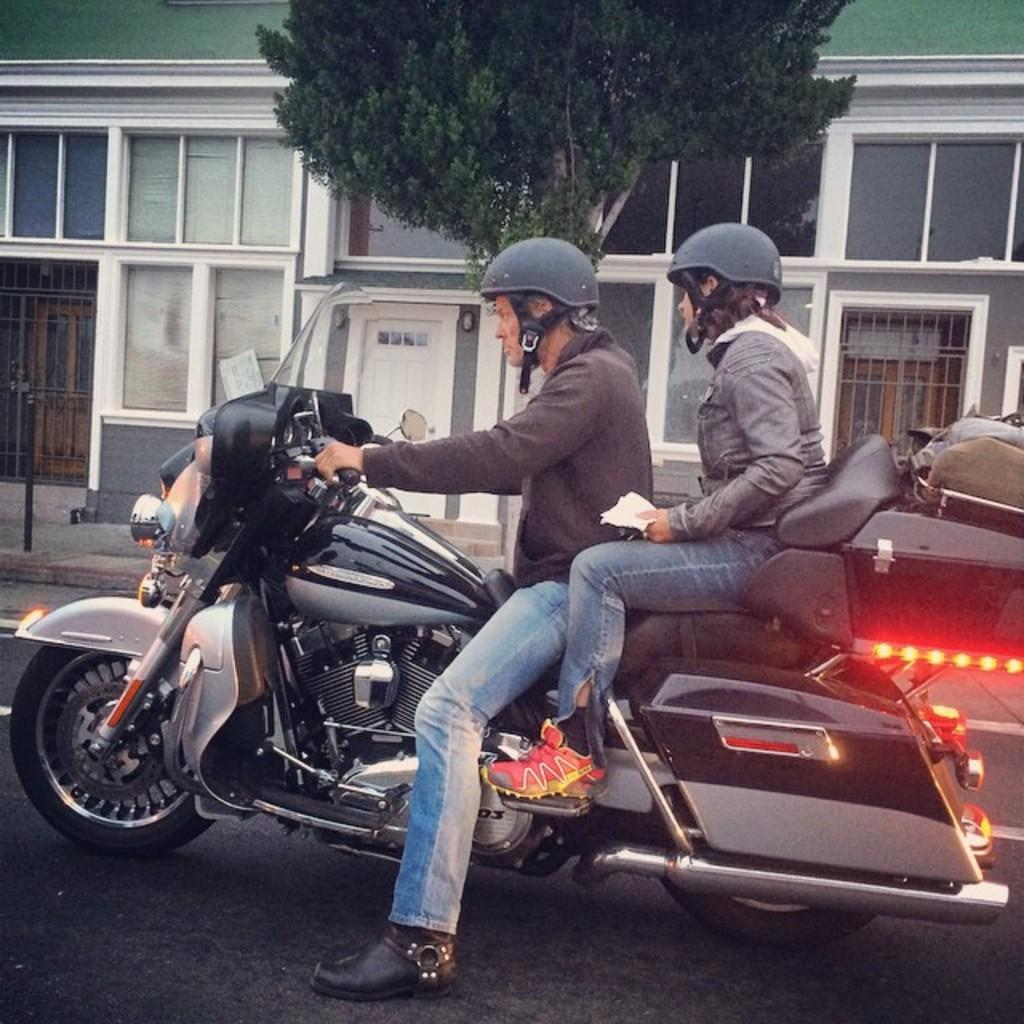How many people are in the image? There are two persons in the image. What are the two persons doing in the image? The two persons are riding a bike. What can be seen in the background of the image? There is a building and a tree in the background of the image. What type of vegetable is being used as a handlebar for the bike in the image? There is no vegetable being used as a handlebar for the bike in the image. 